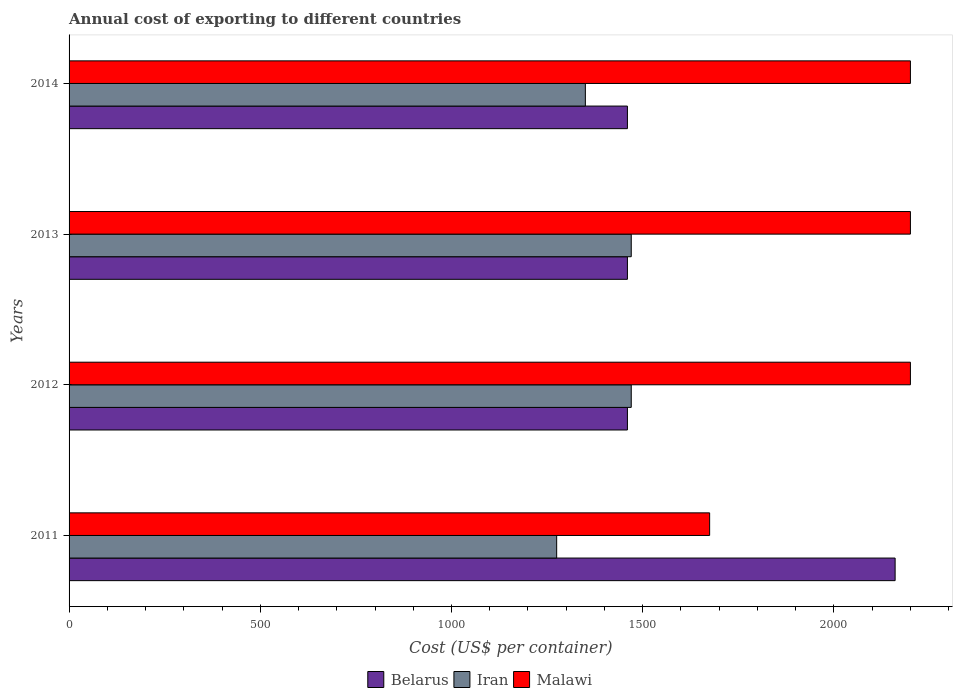How many different coloured bars are there?
Give a very brief answer. 3. Are the number of bars per tick equal to the number of legend labels?
Give a very brief answer. Yes. Are the number of bars on each tick of the Y-axis equal?
Provide a succinct answer. Yes. How many bars are there on the 1st tick from the top?
Your answer should be very brief. 3. What is the label of the 1st group of bars from the top?
Offer a terse response. 2014. What is the total annual cost of exporting in Iran in 2014?
Make the answer very short. 1350. Across all years, what is the maximum total annual cost of exporting in Iran?
Provide a succinct answer. 1470. Across all years, what is the minimum total annual cost of exporting in Iran?
Provide a short and direct response. 1275. What is the total total annual cost of exporting in Belarus in the graph?
Ensure brevity in your answer.  6540. What is the difference between the total annual cost of exporting in Iran in 2014 and the total annual cost of exporting in Belarus in 2012?
Provide a short and direct response. -110. What is the average total annual cost of exporting in Iran per year?
Offer a very short reply. 1391.25. In the year 2013, what is the difference between the total annual cost of exporting in Belarus and total annual cost of exporting in Iran?
Ensure brevity in your answer.  -10. In how many years, is the total annual cost of exporting in Malawi greater than 500 US$?
Make the answer very short. 4. What is the ratio of the total annual cost of exporting in Iran in 2011 to that in 2012?
Provide a succinct answer. 0.87. Is the difference between the total annual cost of exporting in Belarus in 2012 and 2013 greater than the difference between the total annual cost of exporting in Iran in 2012 and 2013?
Your response must be concise. No. What is the difference between the highest and the second highest total annual cost of exporting in Iran?
Provide a succinct answer. 0. What is the difference between the highest and the lowest total annual cost of exporting in Belarus?
Provide a short and direct response. 700. Is the sum of the total annual cost of exporting in Malawi in 2011 and 2012 greater than the maximum total annual cost of exporting in Iran across all years?
Make the answer very short. Yes. What does the 3rd bar from the top in 2014 represents?
Ensure brevity in your answer.  Belarus. What does the 2nd bar from the bottom in 2012 represents?
Your answer should be very brief. Iran. Are all the bars in the graph horizontal?
Your answer should be very brief. Yes. What is the difference between two consecutive major ticks on the X-axis?
Your answer should be compact. 500. How are the legend labels stacked?
Your answer should be compact. Horizontal. What is the title of the graph?
Ensure brevity in your answer.  Annual cost of exporting to different countries. Does "Guinea" appear as one of the legend labels in the graph?
Keep it short and to the point. No. What is the label or title of the X-axis?
Provide a short and direct response. Cost (US$ per container). What is the Cost (US$ per container) of Belarus in 2011?
Give a very brief answer. 2160. What is the Cost (US$ per container) in Iran in 2011?
Offer a terse response. 1275. What is the Cost (US$ per container) of Malawi in 2011?
Provide a succinct answer. 1675. What is the Cost (US$ per container) in Belarus in 2012?
Provide a succinct answer. 1460. What is the Cost (US$ per container) of Iran in 2012?
Give a very brief answer. 1470. What is the Cost (US$ per container) of Malawi in 2012?
Make the answer very short. 2200. What is the Cost (US$ per container) in Belarus in 2013?
Your answer should be compact. 1460. What is the Cost (US$ per container) of Iran in 2013?
Your answer should be very brief. 1470. What is the Cost (US$ per container) of Malawi in 2013?
Keep it short and to the point. 2200. What is the Cost (US$ per container) of Belarus in 2014?
Make the answer very short. 1460. What is the Cost (US$ per container) in Iran in 2014?
Your answer should be compact. 1350. What is the Cost (US$ per container) of Malawi in 2014?
Provide a short and direct response. 2200. Across all years, what is the maximum Cost (US$ per container) in Belarus?
Keep it short and to the point. 2160. Across all years, what is the maximum Cost (US$ per container) in Iran?
Keep it short and to the point. 1470. Across all years, what is the maximum Cost (US$ per container) in Malawi?
Offer a very short reply. 2200. Across all years, what is the minimum Cost (US$ per container) of Belarus?
Your answer should be compact. 1460. Across all years, what is the minimum Cost (US$ per container) in Iran?
Keep it short and to the point. 1275. Across all years, what is the minimum Cost (US$ per container) in Malawi?
Ensure brevity in your answer.  1675. What is the total Cost (US$ per container) in Belarus in the graph?
Your answer should be very brief. 6540. What is the total Cost (US$ per container) of Iran in the graph?
Offer a terse response. 5565. What is the total Cost (US$ per container) in Malawi in the graph?
Ensure brevity in your answer.  8275. What is the difference between the Cost (US$ per container) of Belarus in 2011 and that in 2012?
Offer a very short reply. 700. What is the difference between the Cost (US$ per container) in Iran in 2011 and that in 2012?
Your response must be concise. -195. What is the difference between the Cost (US$ per container) of Malawi in 2011 and that in 2012?
Your answer should be compact. -525. What is the difference between the Cost (US$ per container) of Belarus in 2011 and that in 2013?
Provide a short and direct response. 700. What is the difference between the Cost (US$ per container) of Iran in 2011 and that in 2013?
Your answer should be compact. -195. What is the difference between the Cost (US$ per container) in Malawi in 2011 and that in 2013?
Make the answer very short. -525. What is the difference between the Cost (US$ per container) of Belarus in 2011 and that in 2014?
Offer a very short reply. 700. What is the difference between the Cost (US$ per container) in Iran in 2011 and that in 2014?
Your answer should be compact. -75. What is the difference between the Cost (US$ per container) in Malawi in 2011 and that in 2014?
Your answer should be compact. -525. What is the difference between the Cost (US$ per container) of Malawi in 2012 and that in 2013?
Your answer should be compact. 0. What is the difference between the Cost (US$ per container) of Belarus in 2012 and that in 2014?
Offer a terse response. 0. What is the difference between the Cost (US$ per container) of Iran in 2012 and that in 2014?
Your answer should be very brief. 120. What is the difference between the Cost (US$ per container) of Iran in 2013 and that in 2014?
Make the answer very short. 120. What is the difference between the Cost (US$ per container) in Belarus in 2011 and the Cost (US$ per container) in Iran in 2012?
Offer a terse response. 690. What is the difference between the Cost (US$ per container) in Belarus in 2011 and the Cost (US$ per container) in Malawi in 2012?
Offer a terse response. -40. What is the difference between the Cost (US$ per container) in Iran in 2011 and the Cost (US$ per container) in Malawi in 2012?
Your answer should be very brief. -925. What is the difference between the Cost (US$ per container) in Belarus in 2011 and the Cost (US$ per container) in Iran in 2013?
Keep it short and to the point. 690. What is the difference between the Cost (US$ per container) of Iran in 2011 and the Cost (US$ per container) of Malawi in 2013?
Your response must be concise. -925. What is the difference between the Cost (US$ per container) in Belarus in 2011 and the Cost (US$ per container) in Iran in 2014?
Provide a short and direct response. 810. What is the difference between the Cost (US$ per container) of Iran in 2011 and the Cost (US$ per container) of Malawi in 2014?
Your response must be concise. -925. What is the difference between the Cost (US$ per container) of Belarus in 2012 and the Cost (US$ per container) of Iran in 2013?
Offer a very short reply. -10. What is the difference between the Cost (US$ per container) of Belarus in 2012 and the Cost (US$ per container) of Malawi in 2013?
Offer a very short reply. -740. What is the difference between the Cost (US$ per container) in Iran in 2012 and the Cost (US$ per container) in Malawi in 2013?
Your answer should be very brief. -730. What is the difference between the Cost (US$ per container) of Belarus in 2012 and the Cost (US$ per container) of Iran in 2014?
Provide a short and direct response. 110. What is the difference between the Cost (US$ per container) in Belarus in 2012 and the Cost (US$ per container) in Malawi in 2014?
Offer a very short reply. -740. What is the difference between the Cost (US$ per container) in Iran in 2012 and the Cost (US$ per container) in Malawi in 2014?
Your response must be concise. -730. What is the difference between the Cost (US$ per container) of Belarus in 2013 and the Cost (US$ per container) of Iran in 2014?
Your answer should be very brief. 110. What is the difference between the Cost (US$ per container) of Belarus in 2013 and the Cost (US$ per container) of Malawi in 2014?
Provide a short and direct response. -740. What is the difference between the Cost (US$ per container) of Iran in 2013 and the Cost (US$ per container) of Malawi in 2014?
Provide a succinct answer. -730. What is the average Cost (US$ per container) in Belarus per year?
Provide a succinct answer. 1635. What is the average Cost (US$ per container) in Iran per year?
Provide a short and direct response. 1391.25. What is the average Cost (US$ per container) of Malawi per year?
Offer a very short reply. 2068.75. In the year 2011, what is the difference between the Cost (US$ per container) in Belarus and Cost (US$ per container) in Iran?
Ensure brevity in your answer.  885. In the year 2011, what is the difference between the Cost (US$ per container) in Belarus and Cost (US$ per container) in Malawi?
Give a very brief answer. 485. In the year 2011, what is the difference between the Cost (US$ per container) in Iran and Cost (US$ per container) in Malawi?
Keep it short and to the point. -400. In the year 2012, what is the difference between the Cost (US$ per container) in Belarus and Cost (US$ per container) in Iran?
Your answer should be very brief. -10. In the year 2012, what is the difference between the Cost (US$ per container) of Belarus and Cost (US$ per container) of Malawi?
Your answer should be compact. -740. In the year 2012, what is the difference between the Cost (US$ per container) of Iran and Cost (US$ per container) of Malawi?
Ensure brevity in your answer.  -730. In the year 2013, what is the difference between the Cost (US$ per container) in Belarus and Cost (US$ per container) in Iran?
Offer a terse response. -10. In the year 2013, what is the difference between the Cost (US$ per container) in Belarus and Cost (US$ per container) in Malawi?
Your answer should be compact. -740. In the year 2013, what is the difference between the Cost (US$ per container) in Iran and Cost (US$ per container) in Malawi?
Ensure brevity in your answer.  -730. In the year 2014, what is the difference between the Cost (US$ per container) in Belarus and Cost (US$ per container) in Iran?
Keep it short and to the point. 110. In the year 2014, what is the difference between the Cost (US$ per container) of Belarus and Cost (US$ per container) of Malawi?
Keep it short and to the point. -740. In the year 2014, what is the difference between the Cost (US$ per container) of Iran and Cost (US$ per container) of Malawi?
Keep it short and to the point. -850. What is the ratio of the Cost (US$ per container) in Belarus in 2011 to that in 2012?
Offer a terse response. 1.48. What is the ratio of the Cost (US$ per container) in Iran in 2011 to that in 2012?
Your answer should be compact. 0.87. What is the ratio of the Cost (US$ per container) in Malawi in 2011 to that in 2012?
Make the answer very short. 0.76. What is the ratio of the Cost (US$ per container) of Belarus in 2011 to that in 2013?
Offer a very short reply. 1.48. What is the ratio of the Cost (US$ per container) of Iran in 2011 to that in 2013?
Give a very brief answer. 0.87. What is the ratio of the Cost (US$ per container) of Malawi in 2011 to that in 2013?
Ensure brevity in your answer.  0.76. What is the ratio of the Cost (US$ per container) of Belarus in 2011 to that in 2014?
Offer a very short reply. 1.48. What is the ratio of the Cost (US$ per container) of Iran in 2011 to that in 2014?
Offer a terse response. 0.94. What is the ratio of the Cost (US$ per container) in Malawi in 2011 to that in 2014?
Keep it short and to the point. 0.76. What is the ratio of the Cost (US$ per container) in Belarus in 2012 to that in 2013?
Your response must be concise. 1. What is the ratio of the Cost (US$ per container) of Iran in 2012 to that in 2013?
Ensure brevity in your answer.  1. What is the ratio of the Cost (US$ per container) of Malawi in 2012 to that in 2013?
Offer a very short reply. 1. What is the ratio of the Cost (US$ per container) of Belarus in 2012 to that in 2014?
Your answer should be very brief. 1. What is the ratio of the Cost (US$ per container) of Iran in 2012 to that in 2014?
Make the answer very short. 1.09. What is the ratio of the Cost (US$ per container) in Malawi in 2012 to that in 2014?
Keep it short and to the point. 1. What is the ratio of the Cost (US$ per container) of Belarus in 2013 to that in 2014?
Offer a very short reply. 1. What is the ratio of the Cost (US$ per container) in Iran in 2013 to that in 2014?
Offer a terse response. 1.09. What is the ratio of the Cost (US$ per container) in Malawi in 2013 to that in 2014?
Your answer should be very brief. 1. What is the difference between the highest and the second highest Cost (US$ per container) in Belarus?
Your response must be concise. 700. What is the difference between the highest and the second highest Cost (US$ per container) of Iran?
Your answer should be compact. 0. What is the difference between the highest and the second highest Cost (US$ per container) in Malawi?
Offer a very short reply. 0. What is the difference between the highest and the lowest Cost (US$ per container) in Belarus?
Your response must be concise. 700. What is the difference between the highest and the lowest Cost (US$ per container) in Iran?
Offer a very short reply. 195. What is the difference between the highest and the lowest Cost (US$ per container) in Malawi?
Ensure brevity in your answer.  525. 